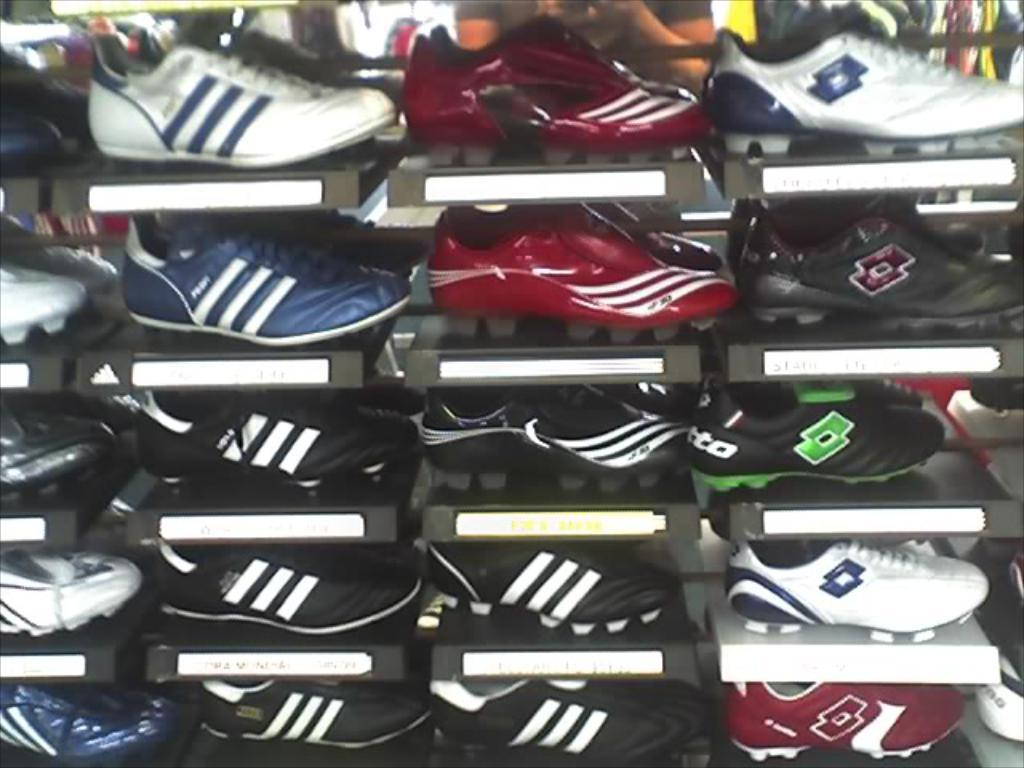What objects are present in the image? There are shoes in the image. How are the shoes arranged in the image? The shoes are kept in shelves. What type of waste is being disposed of in the image? There is no waste present in the image; it only features shoes kept in shelves. 